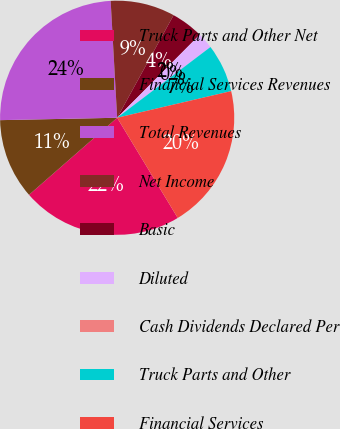Convert chart. <chart><loc_0><loc_0><loc_500><loc_500><pie_chart><fcel>Truck Parts and Other Net<fcel>Financial Services Revenues<fcel>Total Revenues<fcel>Net Income<fcel>Basic<fcel>Diluted<fcel>Cash Dividends Declared Per<fcel>Truck Parts and Other<fcel>Financial Services<nl><fcel>22.22%<fcel>11.11%<fcel>24.44%<fcel>8.89%<fcel>4.45%<fcel>2.22%<fcel>0.0%<fcel>6.67%<fcel>20.0%<nl></chart> 